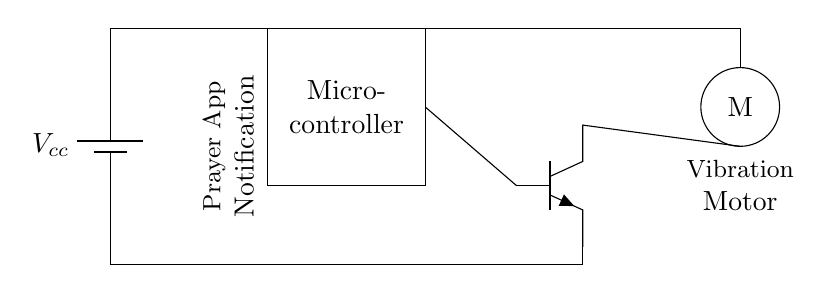What is the main component that controls the vibration motor? The main component controlling the vibration motor is the transistor, indicated by the npn symbol in the diagram. It acts as a switch, allowing current to flow to the motor when activated by the microcontroller.
Answer: transistor What type of battery is used in this circuit? The circuit uses a battery, which is represented by the symbol labeled with $V_{cc}$. This indicates a constant voltage source providing power to the circuit.
Answer: battery What does the abbreviation 'M' represent in the diagram? The 'M' within a circle indicates the vibration motor, which is the component responsible for producing the vibration notification in the prayer app system.
Answer: vibration motor In which part of the circuit is the prayer app notification function indicated? The prayer app notification function is indicated near the microcontroller, labeled within a description that points out its role in managing the notifications.
Answer: microcontroller What is the purpose of the vibration motor in this circuit? The purpose of the vibration motor is to provide tactile feedback or notifications for the prayer app, alerting users without sound. It is designed to vibrate when activated by the microcontroller through the transistor.
Answer: provide notifications How does the microcontroller activate the vibration motor? The microcontroller activates the vibration motor by sending a control signal to the base of the transistor. This signal enables the transistor to allow current to flow from its collector to the emitter, powering the vibration motor.
Answer: by sending a control signal What is the role of the transistor in this circuit? The transistor functions as a switch, controlling the flow of current to the vibration motor based on the input signal from the microcontroller. It essentially acts as an electronic switch to turn the motor on and off as needed.
Answer: switch 